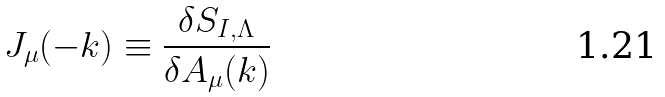Convert formula to latex. <formula><loc_0><loc_0><loc_500><loc_500>J _ { \mu } ( - k ) \equiv \frac { \delta S _ { I , \Lambda } } { \delta A _ { \mu } ( k ) }</formula> 